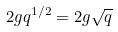<formula> <loc_0><loc_0><loc_500><loc_500>2 g q ^ { 1 / 2 } = 2 g \sqrt { q }</formula> 